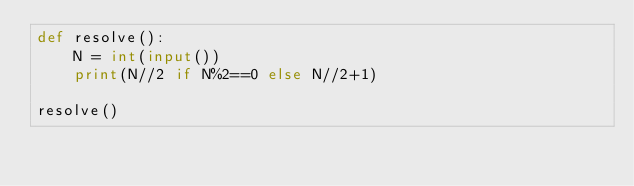Convert code to text. <code><loc_0><loc_0><loc_500><loc_500><_Python_>def resolve():
    N = int(input())
    print(N//2 if N%2==0 else N//2+1)
    
resolve()</code> 